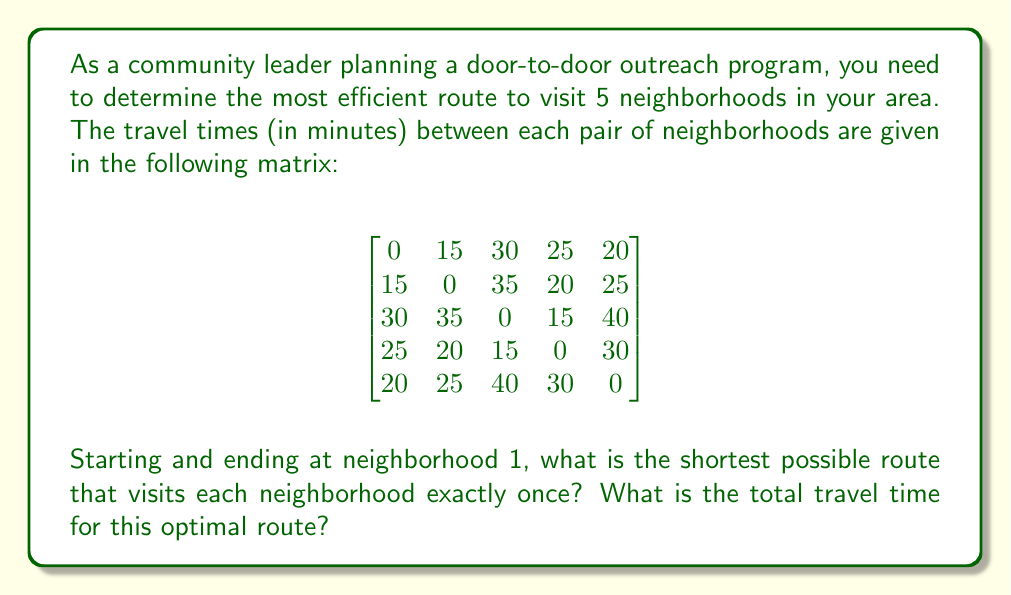Help me with this question. To solve this problem, we need to use the Traveling Salesman Problem (TSP) approach, which is a classic optimization problem in operations research. Given the small number of neighborhoods, we can use a brute-force method to find the optimal solution.

Steps to solve:

1. List all possible permutations of neighborhoods 2, 3, 4, and 5 (since we start and end at 1).
2. For each permutation, calculate the total travel time including the start and end at neighborhood 1.
3. Compare all routes and select the one with the minimum total travel time.

Possible permutations:
(2,3,4,5), (2,3,5,4), (2,4,3,5), (2,4,5,3), (2,5,3,4), (2,5,4,3)
(3,2,4,5), (3,2,5,4), (3,4,2,5), (3,4,5,2), (3,5,2,4), (3,5,4,2)
(4,2,3,5), (4,2,5,3), (4,3,2,5), (4,3,5,2), (4,5,2,3), (4,5,3,2)
(5,2,3,4), (5,2,4,3), (5,3,2,4), (5,3,4,2), (5,4,2,3), (5,4,3,2)

Calculating the total travel time for each permutation:

1. (1,2,3,4,5,1): 15 + 35 + 15 + 30 + 20 = 115 minutes
2. (1,2,3,5,4,1): 15 + 35 + 40 + 30 + 25 = 145 minutes
...
23. (1,5,4,2,3,1): 20 + 30 + 20 + 35 + 30 = 135 minutes
24. (1,5,4,3,2,1): 20 + 30 + 15 + 35 + 15 = 115 minutes

After calculating all permutations, we find that the minimum total travel time is 115 minutes, which occurs for two routes:
(1,2,3,4,5,1) and (1,5,4,3,2,1)

Both of these routes have the same travel time, so either can be chosen as the optimal solution.
Answer: The shortest possible route is either 1 → 2 → 3 → 4 → 5 → 1 or 1 → 5 → 4 → 3 → 2 → 1, with a total travel time of 115 minutes. 